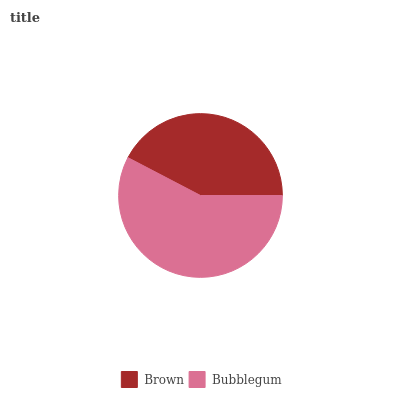Is Brown the minimum?
Answer yes or no. Yes. Is Bubblegum the maximum?
Answer yes or no. Yes. Is Bubblegum the minimum?
Answer yes or no. No. Is Bubblegum greater than Brown?
Answer yes or no. Yes. Is Brown less than Bubblegum?
Answer yes or no. Yes. Is Brown greater than Bubblegum?
Answer yes or no. No. Is Bubblegum less than Brown?
Answer yes or no. No. Is Bubblegum the high median?
Answer yes or no. Yes. Is Brown the low median?
Answer yes or no. Yes. Is Brown the high median?
Answer yes or no. No. Is Bubblegum the low median?
Answer yes or no. No. 